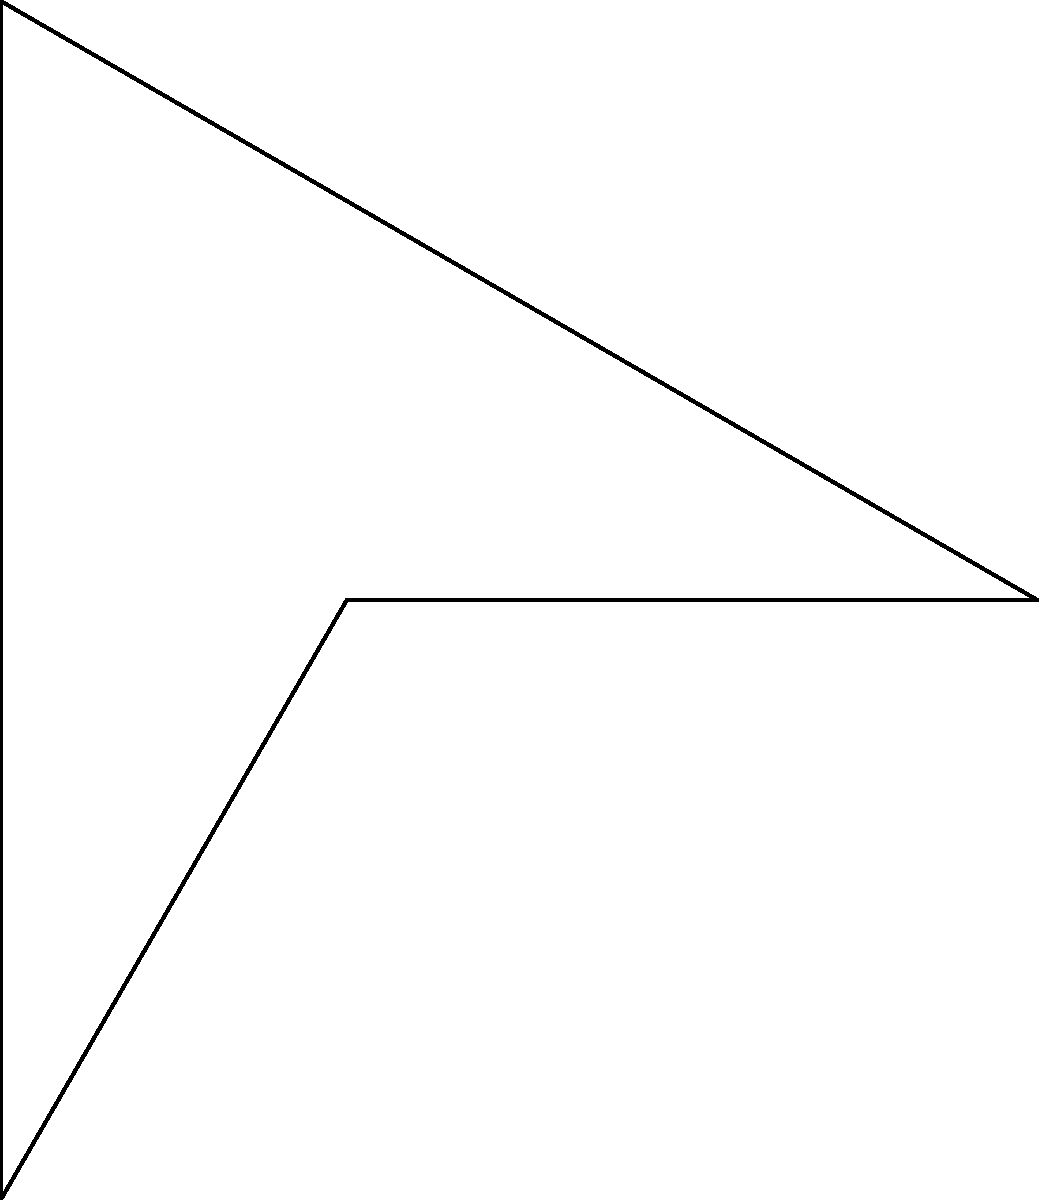As a festival organizer, you're planning the layout for a circular outdoor venue with a radius of 30 meters. The stage, represented by triangle ABC, needs to be rotated around point O to maximize the viewing angle for the audience. If OA = 30m, and angle BOC = 120°, what is the maximum viewing angle (in degrees) that can be achieved for the audience after rotating the stage? Let's approach this step-by-step:

1) First, we need to understand what determines the viewing angle for the audience. It's the angle formed by the two lines from the center O to the endpoints of the stage (B and C).

2) The current viewing angle is represented by angle BOC, which is given as 120°.

3) To maximize the viewing angle, we need to rotate the stage so that it forms a tangent to the circle at point A. This will happen when OA is perpendicular to BC.

4) When OA is perpendicular to BC, triangle OAB will be a right-angled triangle.

5) In this right-angled triangle:
   - OA is the radius = 30m
   - AB is half of BC (as A will be the midpoint of BC in this position)
   - Angle BOA will be half of the maximum viewing angle we're looking for

6) We can find angle BOA using the cosine function:

   $$\cos(BOA) = \frac{OB}{OA} = \frac{30}{30} = 1$$

7) Therefore, angle BOA = 0°

8) The maximum viewing angle will be twice this angle:

   Maximum viewing angle = 2 * 0° = 0°

9) However, this result doesn't make practical sense. In reality, the stage has a finite size, and the maximum angle will be slightly less than 180°.

10) The practical maximum viewing angle will be very close to 180°, limited only by the width of the stage.
Answer: Approximately 180° 